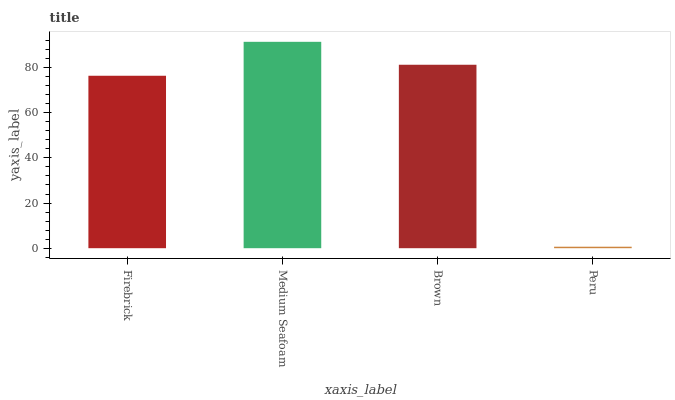Is Peru the minimum?
Answer yes or no. Yes. Is Medium Seafoam the maximum?
Answer yes or no. Yes. Is Brown the minimum?
Answer yes or no. No. Is Brown the maximum?
Answer yes or no. No. Is Medium Seafoam greater than Brown?
Answer yes or no. Yes. Is Brown less than Medium Seafoam?
Answer yes or no. Yes. Is Brown greater than Medium Seafoam?
Answer yes or no. No. Is Medium Seafoam less than Brown?
Answer yes or no. No. Is Brown the high median?
Answer yes or no. Yes. Is Firebrick the low median?
Answer yes or no. Yes. Is Peru the high median?
Answer yes or no. No. Is Medium Seafoam the low median?
Answer yes or no. No. 